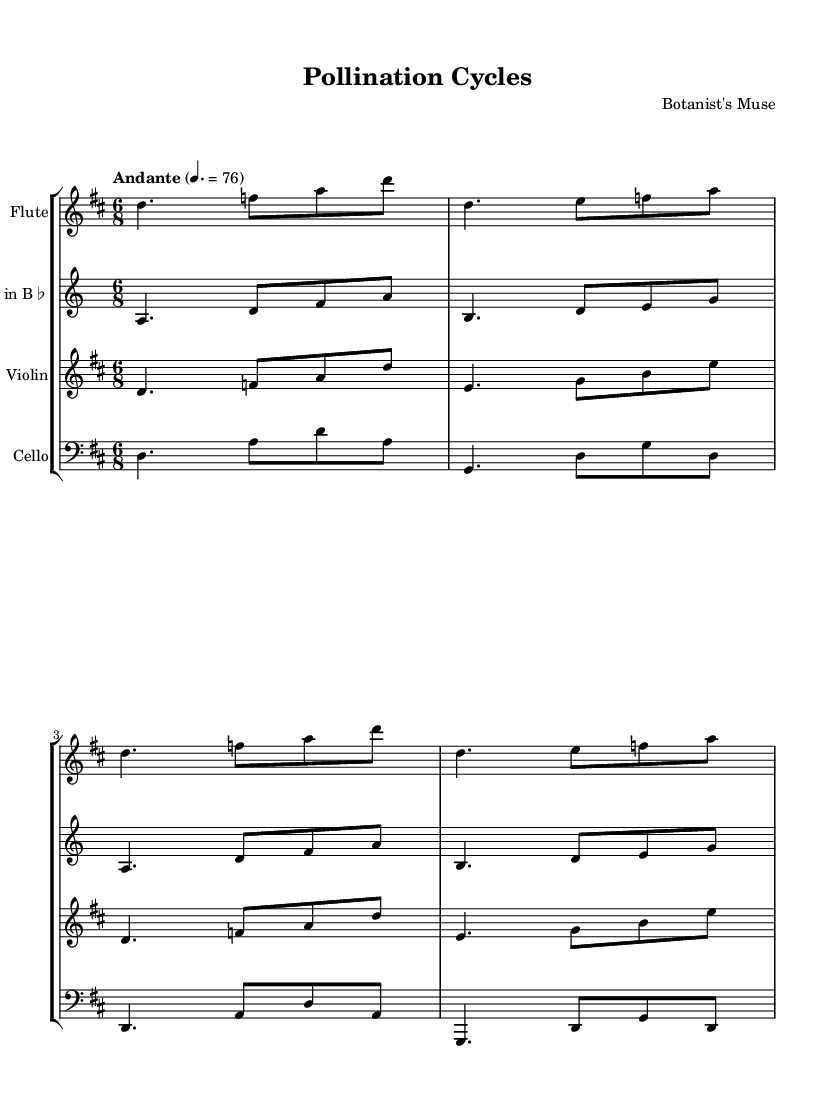What is the key signature of this music? The key signature is indicated by the sharp signs at the beginning of the staff. In this piece, there are two sharps, which correspond to the key of D major.
Answer: D major What is the time signature of this music? The time signature is found at the beginning of the score, written as a fraction. Here, it reads 6/8, indicating there are six eighth notes in each measure.
Answer: 6/8 What is the tempo marking for this piece? The tempo is indicated at the start of the score, marked as "Andante" with a specific metronome marking of 76 beats per minute as indicated beneath it.
Answer: Andante Which instruments are included in this score? The instruments are listed at the beginning of each staff within the score. They include flute, clarinet in B flat, violin, and cello.
Answer: Flute, clarinet in B flat, violin, cello What is the rhythmic pattern of the flute in the first measure? The rhythmic pattern can be determined by analyzing the notes in the first measure of the flute part. It consists of a dotted quarter note followed by two eighth notes.
Answer: Dotted quarter note, two eighth notes How is the texture of this piece created among the instruments? The texture can be analyzed by examining how the instruments interact. In this piece, the instruments play similar rhythmic figures with intertwining melodies, creating a rich, layered texture.
Answer: Intertwining melodies What is a defining characteristic of minimalist chamber music as reflected in this piece? A defining characteristic of minimalist music is the repetitive motifs and cyclical patterns found throughout the piece. This is evident in the way phrases and rhythm are repeated and developed.
Answer: Repetitive motifs 